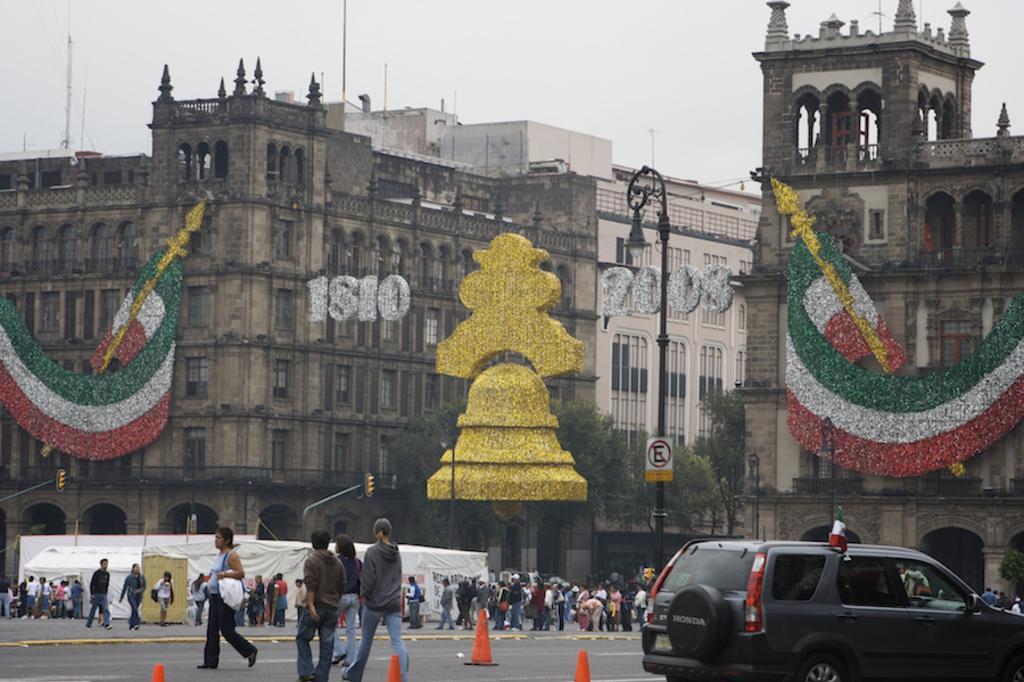Please provide a concise description of this image. In this image I can see group of people walking on the road. In front I can see the vehicle in gray color, background I can see few buildings in cream and brown color, and sky is in white color. 